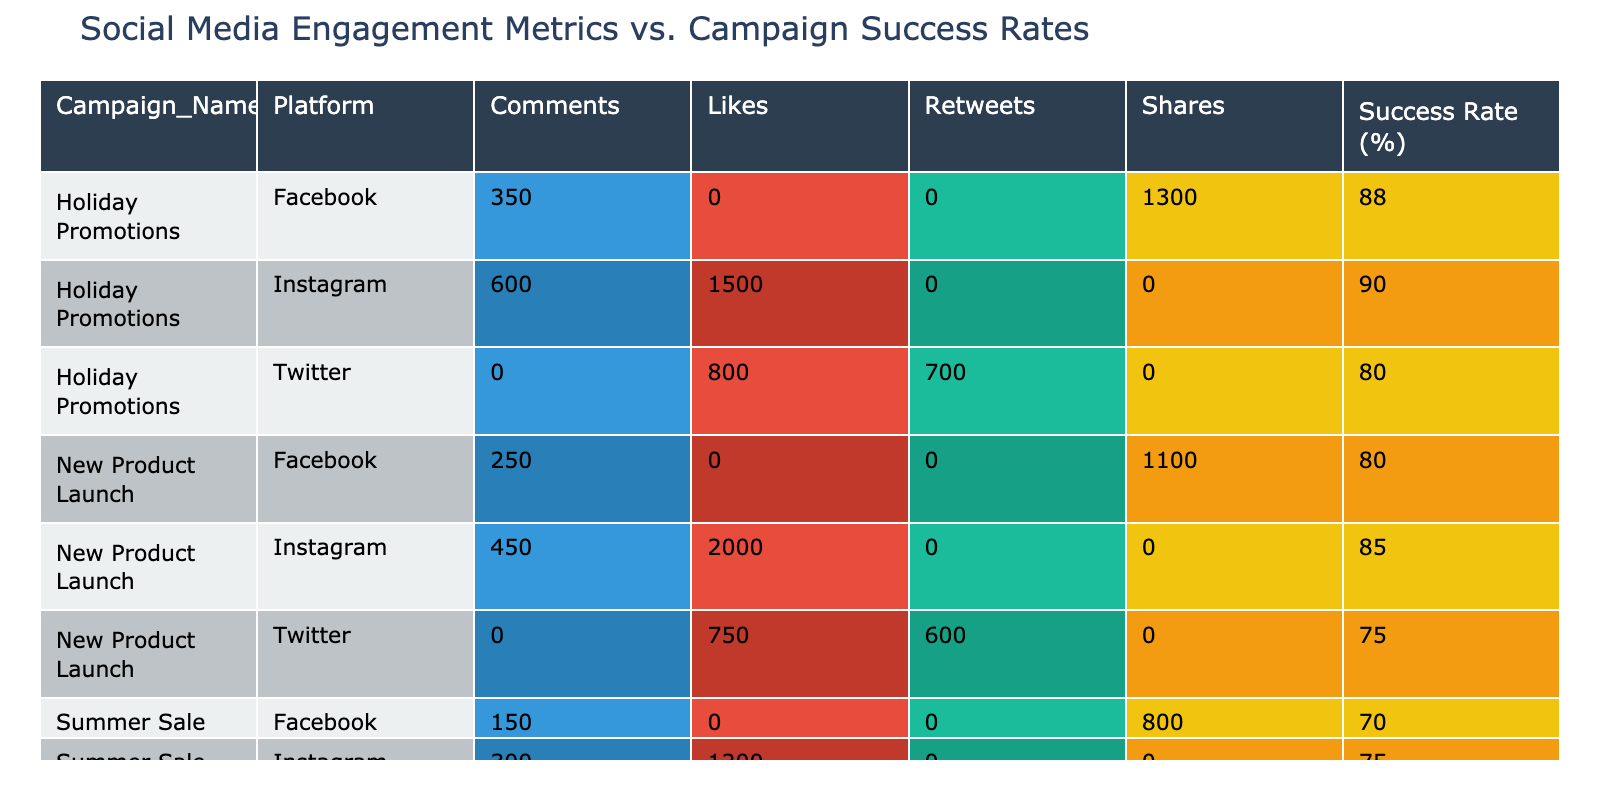What is the success rate of the "Holiday Promotions" campaign on Twitter? Looking at the "Holiday Promotions" row for the Twitter platform, the success rate percentage is listed as 80.
Answer: 80 What is the total engagement value (likes, comments, shares, retweets) for the "New Product Launch" campaign on Instagram? For the "New Product Launch" on Instagram, the engagement values are 2000 (likes) + 450 (comments) = 2450.
Answer: 2450 Is the success rate of the "Summer Sale" campaign on Facebook higher than that on Twitter? The success rate for the "Summer Sale" on Facebook is 70, whereas on Twitter it is 65. Hence, Facebook's success rate is higher.
Answer: Yes What is the average success rate of all campaigns on Instagram? The success rates on Instagram for each campaign are 75 (Summer Sale), 85 (New Product Launch), and 90 (Holiday Promotions). Adding them gives 75 + 85 + 90 = 250, and since there are 3 campaigns, the average is 250 / 3 = approximately 83.33.
Answer: 83.33 How many total likes were received across all campaigns on Facebook? The total likes for Facebook can be found by adding the engagement values: 800 (Summer Sale - shares) + 1100 (New Product Launch - shares) + 1300 (Holiday Promotions - shares) = 3200.
Answer: 3200 What engagement metric contributed the least engagement value in the "Summer Sale" campaign? Analyzing the engagement values for the "Summer Sale," the least value is from comments on Instagram with 300.
Answer: 300 What is the difference in the success rates between the "New Product Launch" and "Summer Sale" campaigns? The success rate for "New Product Launch" is 85 while for "Summer Sale" it is 75. The difference is calculated as 85 - 75 = 10.
Answer: 10 Did the "Holiday Promotions" campaign achieve a higher success rate than the "New Product Launch" campaign across all platforms? For "Holiday Promotions," the success rates are 90 (Instagram), 88 (Facebook), and 80 (Twitter), while for "New Product Launch" they are 85 (Instagram), 80 (Facebook), and 75 (Twitter). Since all success rates for "Holiday Promotions" are higher, the statement is true.
Answer: Yes 